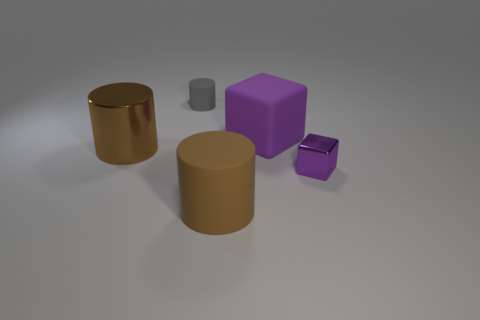How many matte objects are either large brown things or big cubes?
Offer a terse response. 2. There is a large cylinder that is in front of the small purple cube; what is its color?
Offer a terse response. Brown. What shape is the purple rubber object that is the same size as the brown shiny cylinder?
Provide a short and direct response. Cube. Do the big rubber cube and the metallic object on the right side of the big brown matte thing have the same color?
Your answer should be compact. Yes. How many things are either cubes behind the large brown metallic thing or large cylinders that are on the left side of the big brown matte cylinder?
Your answer should be very brief. 2. What material is the purple object that is the same size as the gray cylinder?
Ensure brevity in your answer.  Metal. How many other objects are there of the same material as the tiny purple thing?
Your answer should be compact. 1. Do the metallic thing that is left of the gray rubber thing and the purple thing that is behind the purple shiny block have the same shape?
Provide a succinct answer. No. There is a large cylinder in front of the tiny object in front of the large brown cylinder that is behind the purple metallic thing; what color is it?
Offer a terse response. Brown. How many other objects are the same color as the small matte object?
Offer a very short reply. 0. 